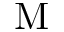Convert formula to latex. <formula><loc_0><loc_0><loc_500><loc_500>M</formula> 